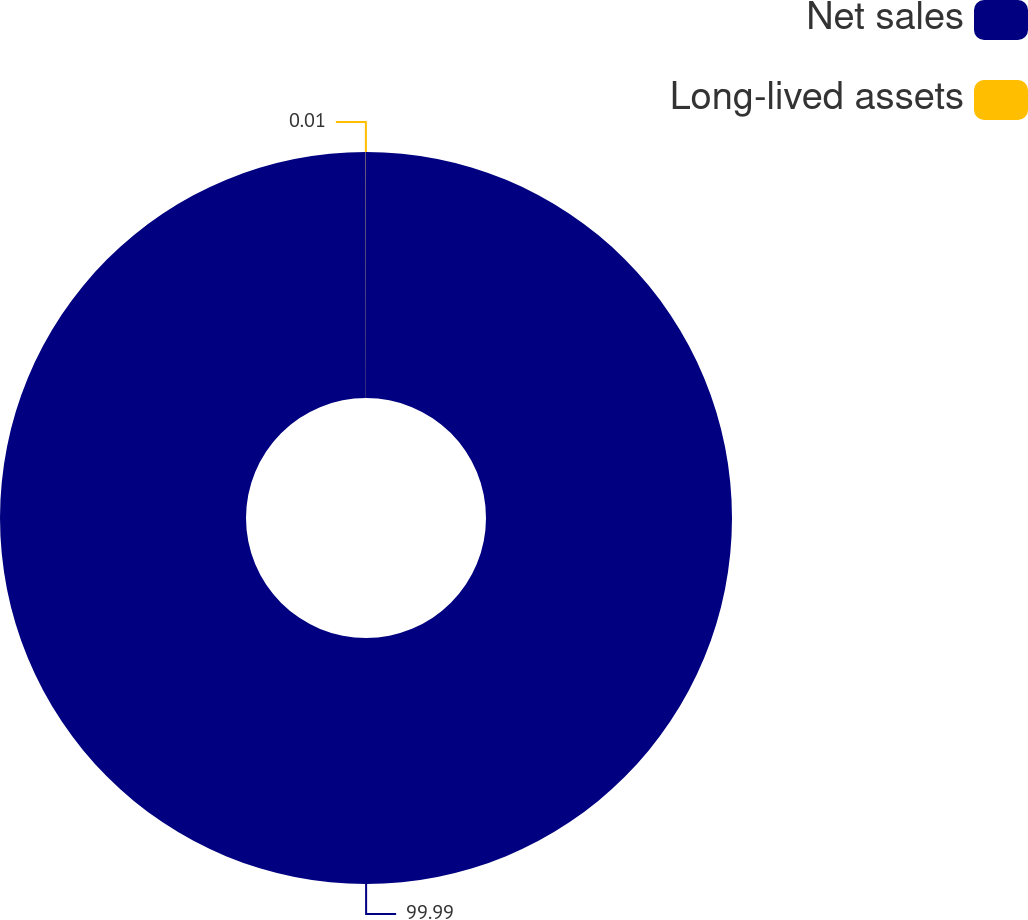<chart> <loc_0><loc_0><loc_500><loc_500><pie_chart><fcel>Net sales<fcel>Long-lived assets<nl><fcel>99.99%<fcel>0.01%<nl></chart> 